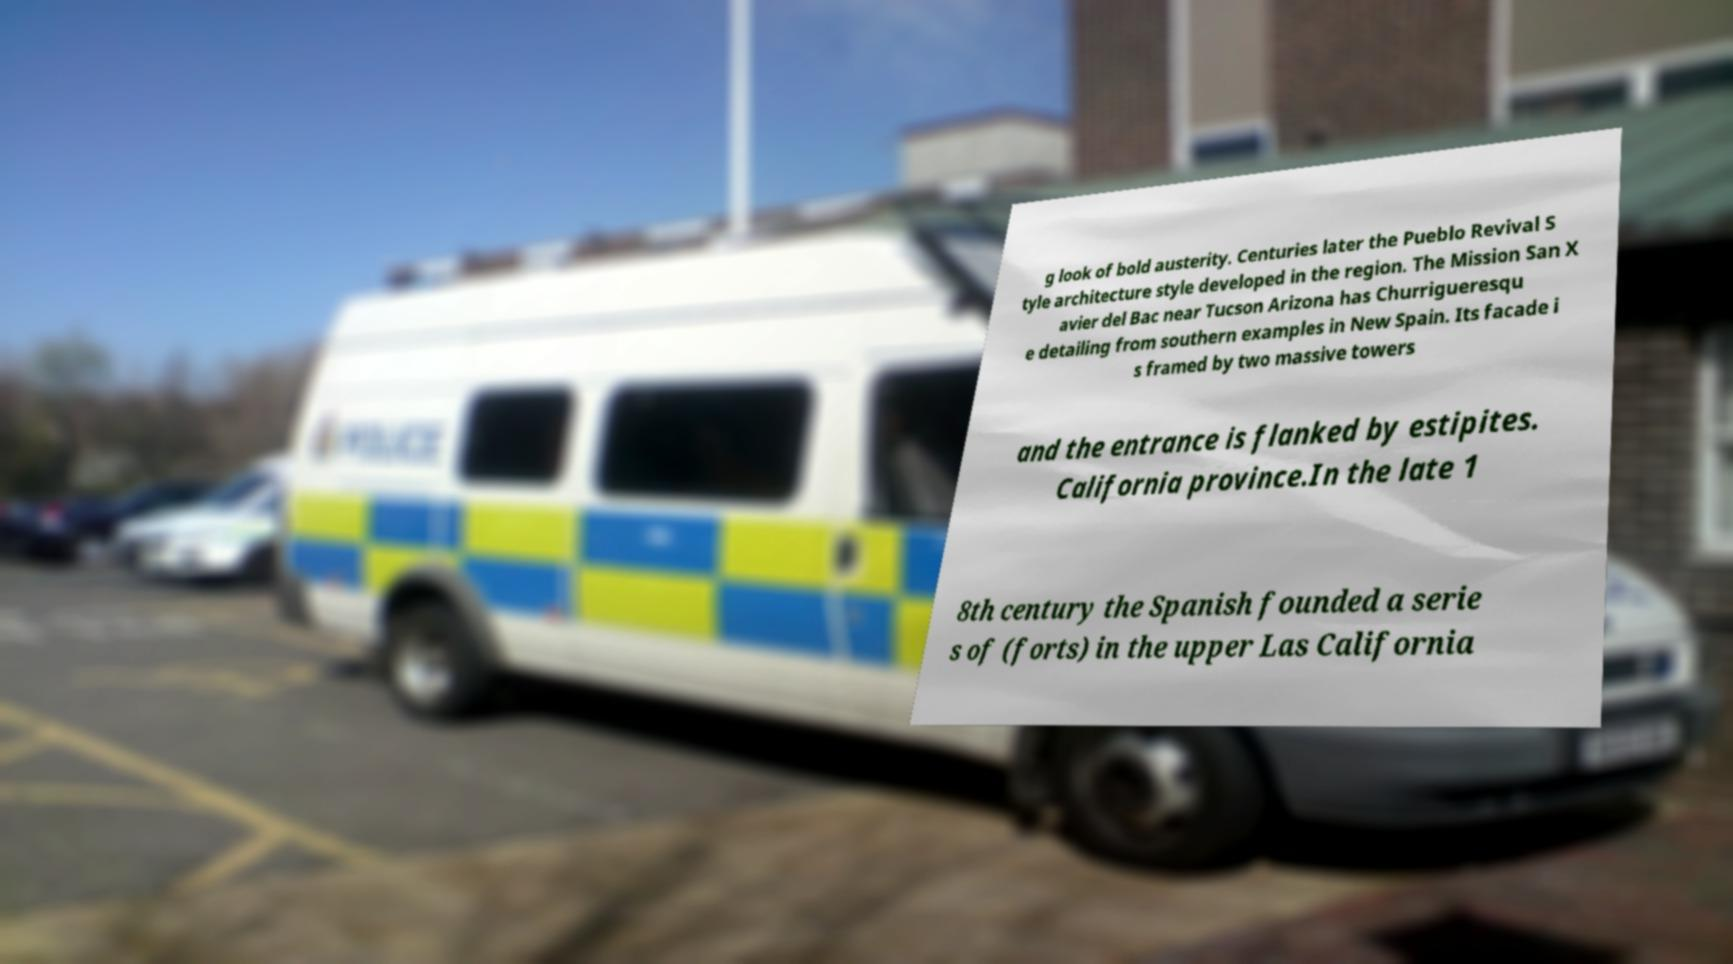What messages or text are displayed in this image? I need them in a readable, typed format. g look of bold austerity. Centuries later the Pueblo Revival S tyle architecture style developed in the region. The Mission San X avier del Bac near Tucson Arizona has Churrigueresqu e detailing from southern examples in New Spain. Its facade i s framed by two massive towers and the entrance is flanked by estipites. California province.In the late 1 8th century the Spanish founded a serie s of (forts) in the upper Las California 